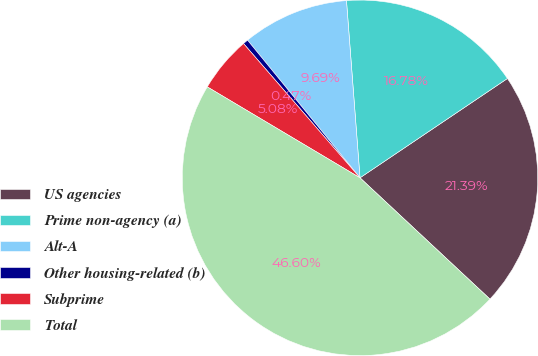Convert chart to OTSL. <chart><loc_0><loc_0><loc_500><loc_500><pie_chart><fcel>US agencies<fcel>Prime non-agency (a)<fcel>Alt-A<fcel>Other housing-related (b)<fcel>Subprime<fcel>Total<nl><fcel>21.39%<fcel>16.78%<fcel>9.69%<fcel>0.47%<fcel>5.08%<fcel>46.6%<nl></chart> 